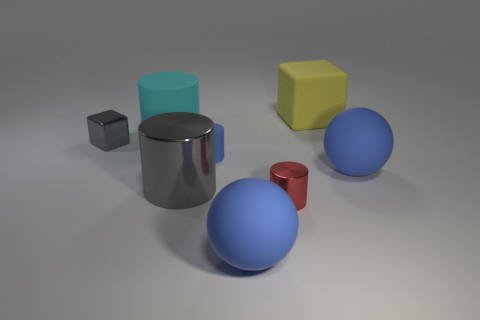Add 1 big matte blocks. How many objects exist? 9 Subtract all cubes. How many objects are left? 6 Subtract 1 red cylinders. How many objects are left? 7 Subtract all tiny gray shiny objects. Subtract all tiny gray shiny blocks. How many objects are left? 6 Add 5 small gray shiny objects. How many small gray shiny objects are left? 6 Add 6 large cyan rubber cubes. How many large cyan rubber cubes exist? 6 